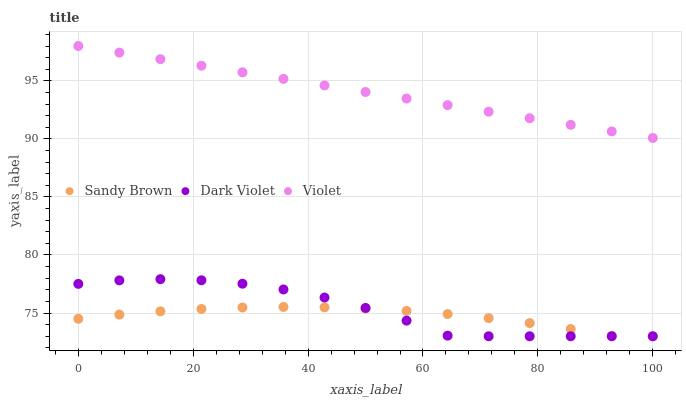Does Sandy Brown have the minimum area under the curve?
Answer yes or no. Yes. Does Violet have the maximum area under the curve?
Answer yes or no. Yes. Does Dark Violet have the minimum area under the curve?
Answer yes or no. No. Does Dark Violet have the maximum area under the curve?
Answer yes or no. No. Is Violet the smoothest?
Answer yes or no. Yes. Is Dark Violet the roughest?
Answer yes or no. Yes. Is Dark Violet the smoothest?
Answer yes or no. No. Is Violet the roughest?
Answer yes or no. No. Does Sandy Brown have the lowest value?
Answer yes or no. Yes. Does Violet have the lowest value?
Answer yes or no. No. Does Violet have the highest value?
Answer yes or no. Yes. Does Dark Violet have the highest value?
Answer yes or no. No. Is Dark Violet less than Violet?
Answer yes or no. Yes. Is Violet greater than Sandy Brown?
Answer yes or no. Yes. Does Sandy Brown intersect Dark Violet?
Answer yes or no. Yes. Is Sandy Brown less than Dark Violet?
Answer yes or no. No. Is Sandy Brown greater than Dark Violet?
Answer yes or no. No. Does Dark Violet intersect Violet?
Answer yes or no. No. 